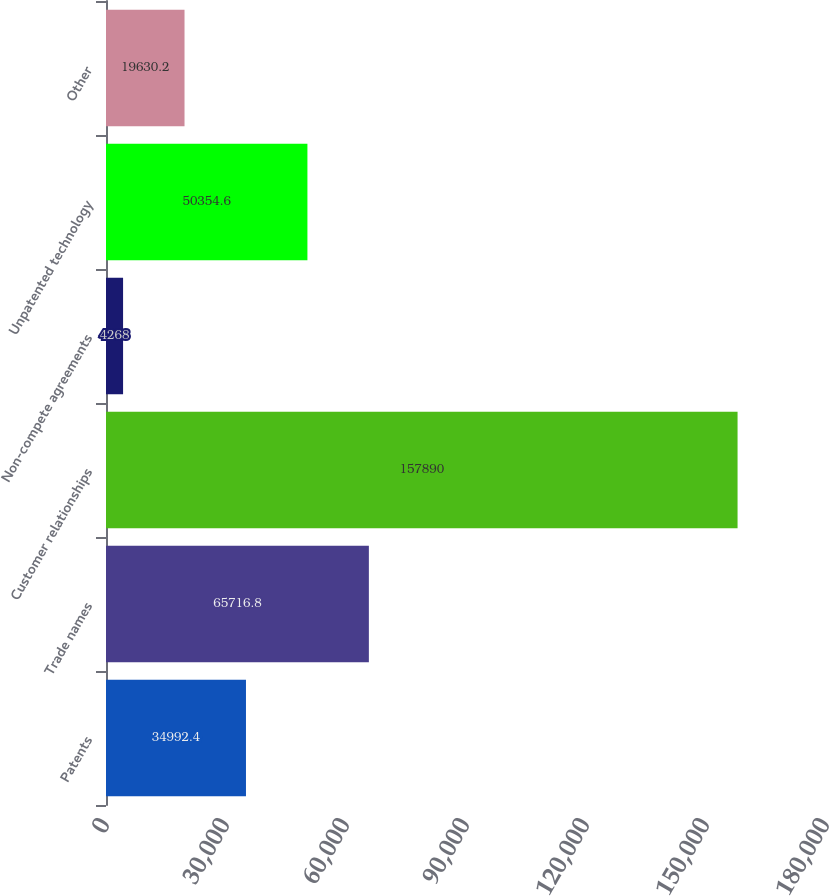<chart> <loc_0><loc_0><loc_500><loc_500><bar_chart><fcel>Patents<fcel>Trade names<fcel>Customer relationships<fcel>Non-compete agreements<fcel>Unpatented technology<fcel>Other<nl><fcel>34992.4<fcel>65716.8<fcel>157890<fcel>4268<fcel>50354.6<fcel>19630.2<nl></chart> 